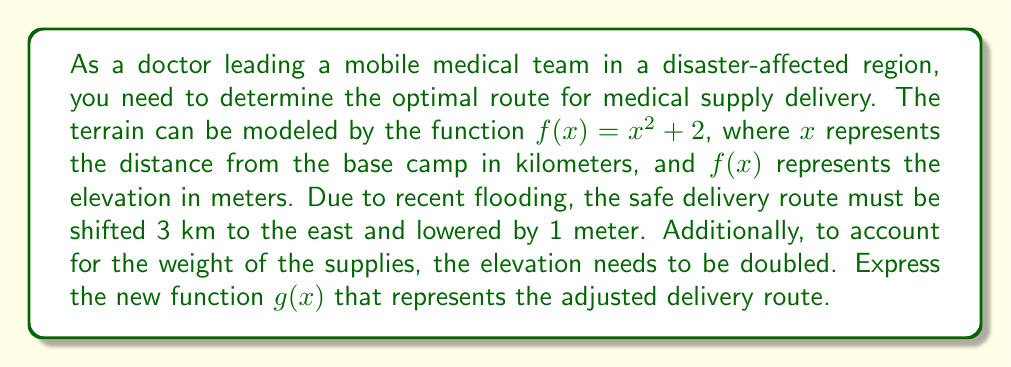Solve this math problem. To solve this problem, we need to apply a series of transformations to the original function $f(x) = x^2 + 2$. Let's break it down step by step:

1. Shift 3 km to the east:
   This is a horizontal shift, represented by replacing $x$ with $(x - 3)$
   $f_1(x) = (x - 3)^2 + 2$

2. Lower by 1 meter:
   This is a vertical shift down, represented by subtracting 1 from the function
   $f_2(x) = (x - 3)^2 + 2 - 1 = (x - 3)^2 + 1$

3. Double the elevation:
   This is a vertical stretch by a factor of 2, represented by multiplying the entire function by 2
   $g(x) = 2[(x - 3)^2 + 1]$

Now, let's expand this final function:
$g(x) = 2(x^2 - 6x + 9 + 1)$
$g(x) = 2(x^2 - 6x + 10)$
$g(x) = 2x^2 - 12x + 20$

This is the final transformed function that represents the adjusted delivery route.
Answer: $g(x) = 2x^2 - 12x + 20$ 